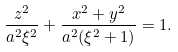<formula> <loc_0><loc_0><loc_500><loc_500>\frac { z ^ { 2 } } { a ^ { 2 } \xi ^ { 2 } } + \frac { x ^ { 2 } + y ^ { 2 } } { a ^ { 2 } ( \xi ^ { 2 } + 1 ) } = 1 .</formula> 